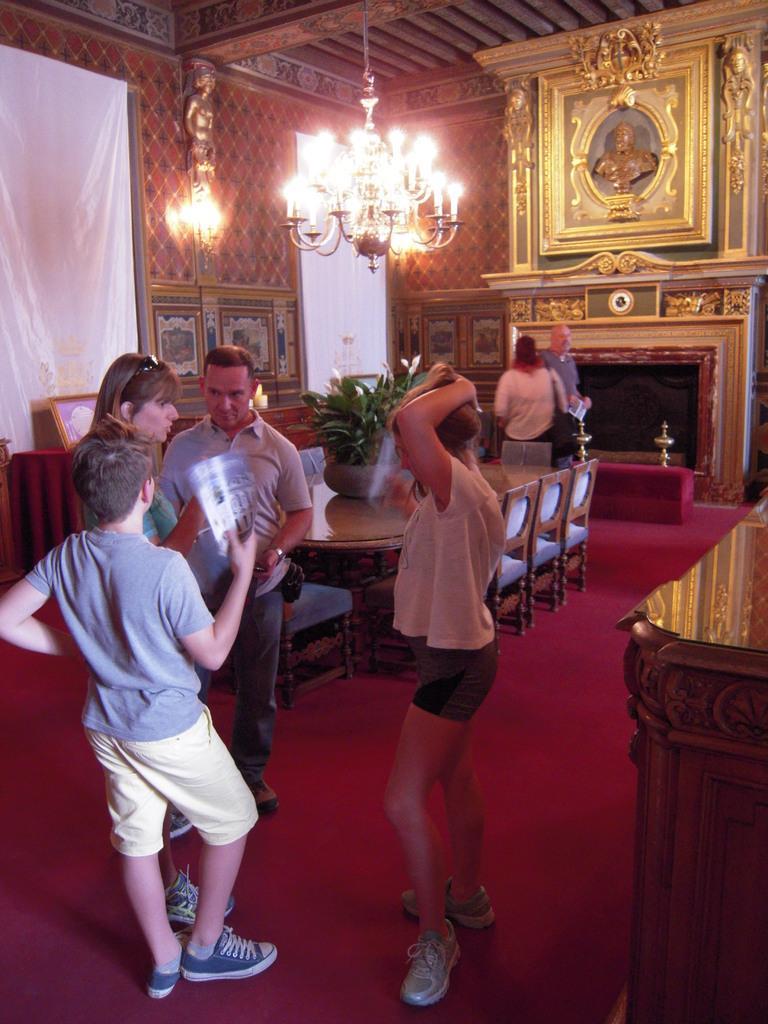Can you describe this image briefly? There is a group of people. They are standing in a room. We can see in the background there is a lights and photo albums,table and flower pot. 